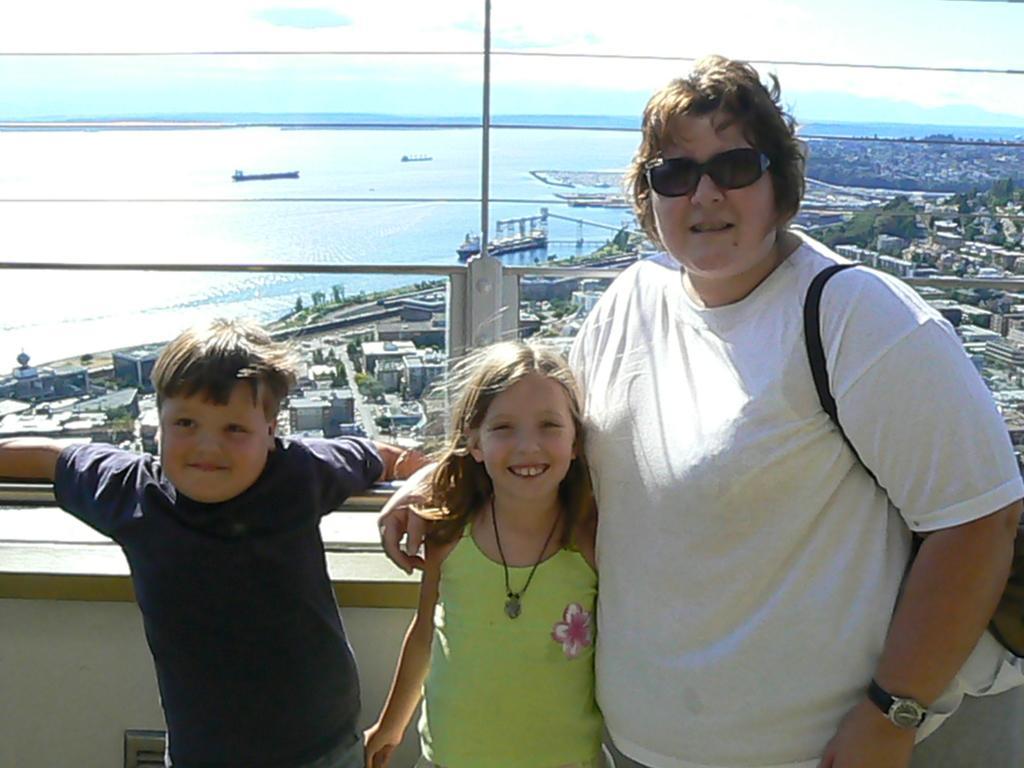Describe this image in one or two sentences. In this image I can see three people with different color dresses and one person is wearing the goggles and the bag. In the back there are many buildings. To the side I can see the water. I can also see the trees and the sky in the back. 